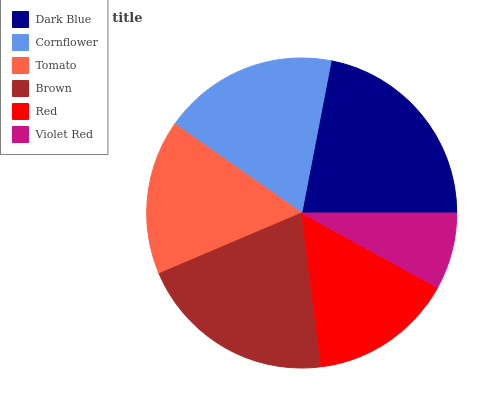Is Violet Red the minimum?
Answer yes or no. Yes. Is Dark Blue the maximum?
Answer yes or no. Yes. Is Cornflower the minimum?
Answer yes or no. No. Is Cornflower the maximum?
Answer yes or no. No. Is Dark Blue greater than Cornflower?
Answer yes or no. Yes. Is Cornflower less than Dark Blue?
Answer yes or no. Yes. Is Cornflower greater than Dark Blue?
Answer yes or no. No. Is Dark Blue less than Cornflower?
Answer yes or no. No. Is Cornflower the high median?
Answer yes or no. Yes. Is Tomato the low median?
Answer yes or no. Yes. Is Violet Red the high median?
Answer yes or no. No. Is Brown the low median?
Answer yes or no. No. 